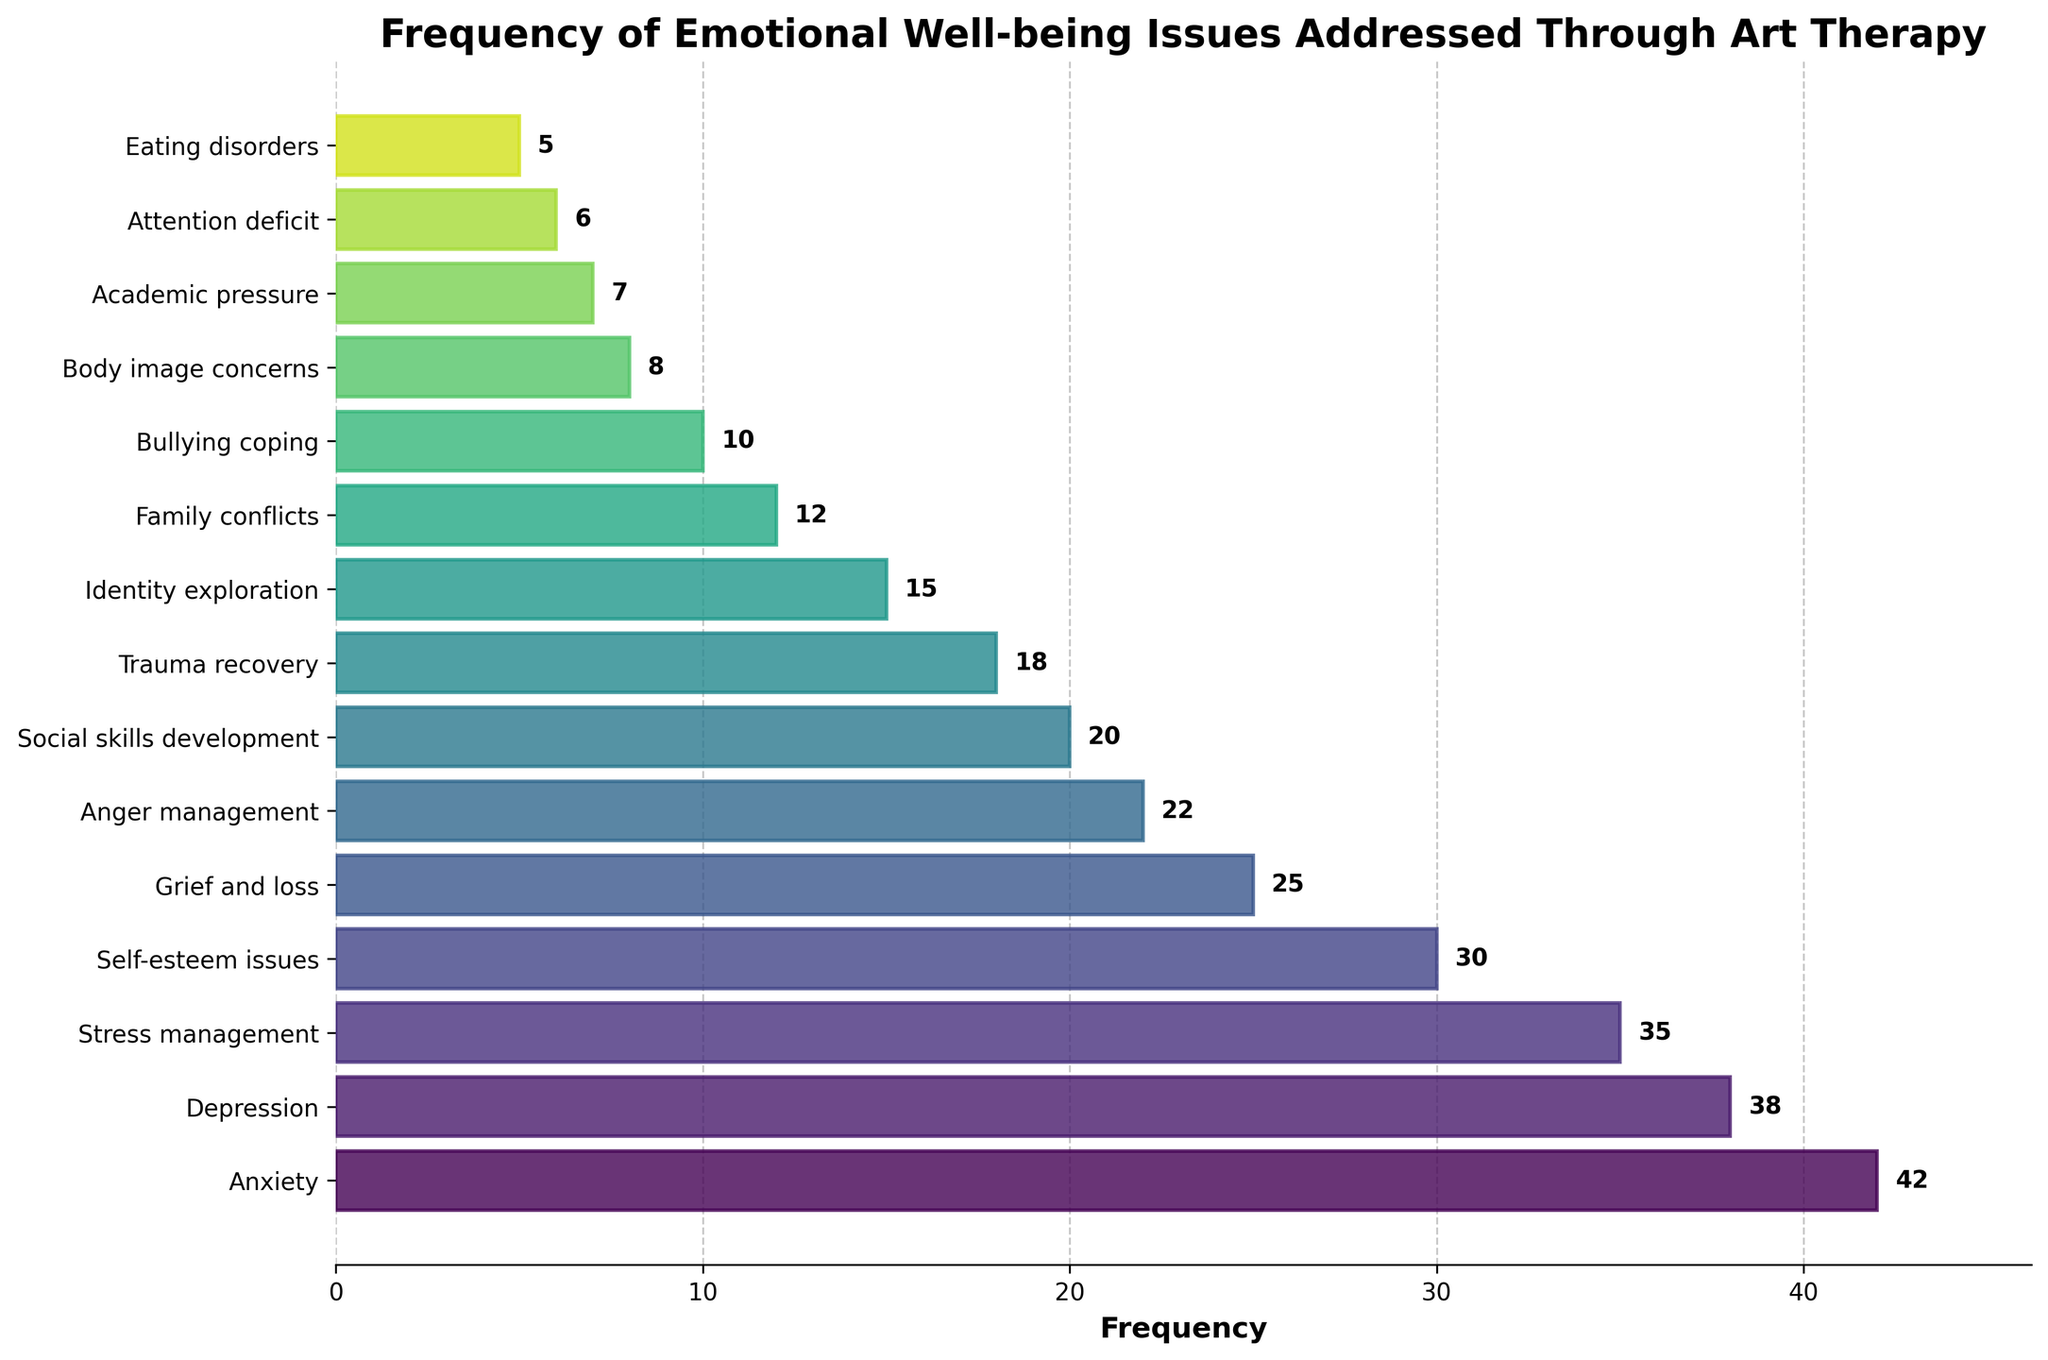Which emotional well-being issue has the highest frequency? Look at the bar that extends the farthest to the right. This represents the issue with the highest frequency. Here, "Anxiety" has the longest bar.
Answer: Anxiety Which emotional well-being issue has the lowest frequency? Look at the bar that is the shortest. This represents the issue with the lowest frequency. Here, "Eating disorders" has the shortest bar.
Answer: Eating disorders What is the total frequency of the top three issues combined? Sum the frequencies of the top three issues: Anxiety (42) + Depression (38) + Stress management (35). So, 42 + 38 + 35 = 115.
Answer: 115 How does the frequency of Self-esteem issues compare to Grief and loss? Compare the lengths of their respective bars. Self-esteem issues has a frequency of 30, while Grief and loss has 25. So, Self-esteem issues is higher.
Answer: Self-esteem issues is higher What is the average frequency of Social skills development, Trauma recovery, and Identity exploration? Add the frequencies of Social skills development (20), Trauma recovery (18), and Identity exploration (15) and divide by 3. So, (20 + 18 + 15) / 3 = 53 / 3 ≈ 17.67.
Answer: 17.67 Which issue has a frequency exactly halfway between the highest and lowest frequency issues? The highest frequency is Anxiety (42) and the lowest is Eating disorders (5). Calculate (42 + 5) / 2 = 47 / 2 = 23. Checking the frequencies in the chart, "Anger management" has a frequency of 22, which is closest to 23.
Answer: Anger management Which color represents the bar for Depression? The bars change color gradually in a spectrum. Depression is the second bar from the top, so check its color in the figure.
Answer: The specific color, typically seen from a color gradient scheme What is the difference in frequency between Bullying coping and Academic pressure? Subtract the frequency of Academic pressure (7) from Bullying coping (10). So, 10 - 7 = 3.
Answer: 3 Is the frequency of Family conflicts more or less than double that of Body image concerns? Double the frequency of Body image concerns (8 * 2 = 16). The frequency of Family conflicts is 12, which is less than 16.
Answer: Less Which issues have a frequency less than 10? Identify bars with lengths representing frequencies less than 10. These are Bullying coping (10), Body image concerns (8), Academic pressure (7), Attention deficit (6), and Eating disorders (5).
Answer: Body image concerns, Academic pressure, Attention deficit, Eating disorders 